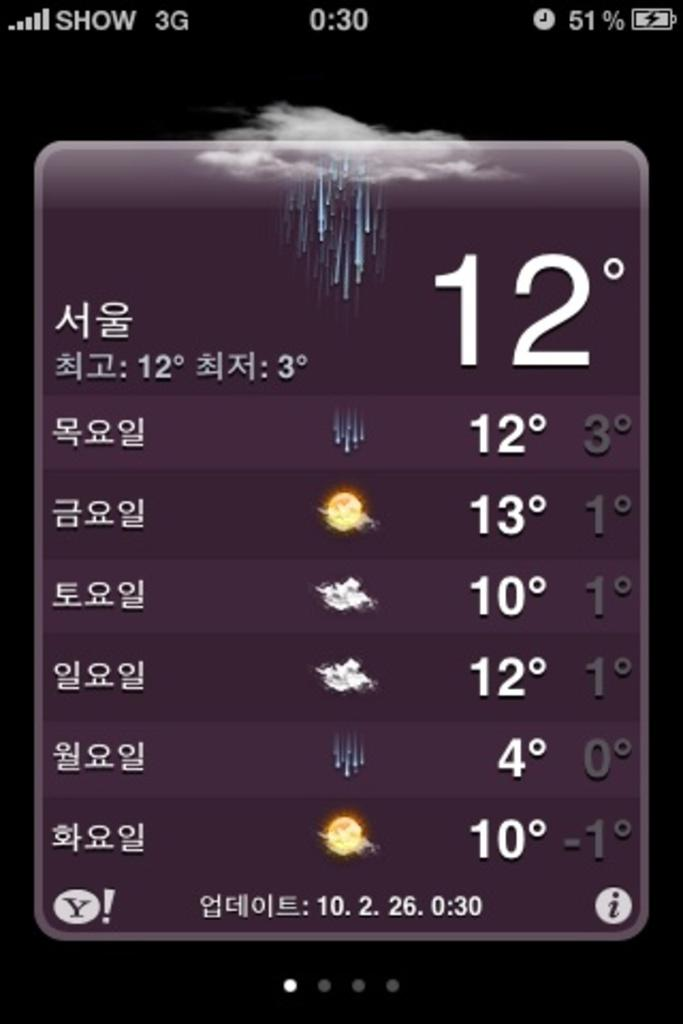What is the main object in the image? There is a screen in the image. What can be seen on the screen? Text and symbols are visible on the screen. How does the brain react to the text on the screen in the image? There is no information about a brain or its reaction in the image; it only shows a screen with text and symbols. 